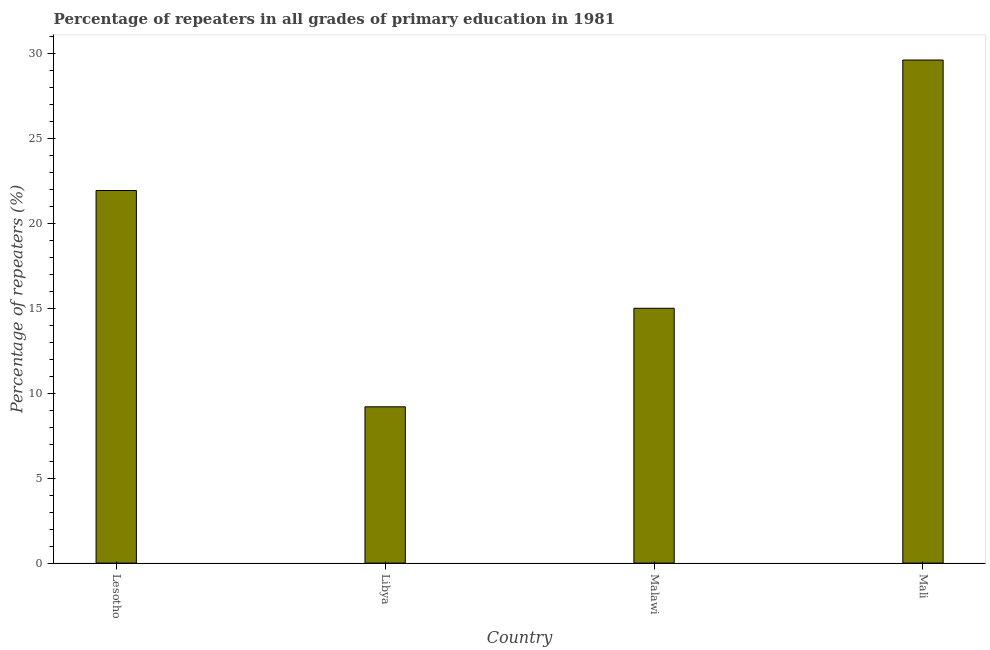Does the graph contain any zero values?
Make the answer very short. No. What is the title of the graph?
Offer a very short reply. Percentage of repeaters in all grades of primary education in 1981. What is the label or title of the X-axis?
Your response must be concise. Country. What is the label or title of the Y-axis?
Your response must be concise. Percentage of repeaters (%). What is the percentage of repeaters in primary education in Mali?
Provide a short and direct response. 29.59. Across all countries, what is the maximum percentage of repeaters in primary education?
Your answer should be very brief. 29.59. Across all countries, what is the minimum percentage of repeaters in primary education?
Give a very brief answer. 9.19. In which country was the percentage of repeaters in primary education maximum?
Your answer should be compact. Mali. In which country was the percentage of repeaters in primary education minimum?
Offer a very short reply. Libya. What is the sum of the percentage of repeaters in primary education?
Ensure brevity in your answer.  75.68. What is the difference between the percentage of repeaters in primary education in Lesotho and Malawi?
Offer a terse response. 6.93. What is the average percentage of repeaters in primary education per country?
Offer a terse response. 18.92. What is the median percentage of repeaters in primary education?
Provide a short and direct response. 18.45. In how many countries, is the percentage of repeaters in primary education greater than 30 %?
Give a very brief answer. 0. What is the ratio of the percentage of repeaters in primary education in Lesotho to that in Malawi?
Offer a terse response. 1.46. What is the difference between the highest and the second highest percentage of repeaters in primary education?
Your answer should be compact. 7.67. What is the difference between the highest and the lowest percentage of repeaters in primary education?
Your answer should be compact. 20.4. In how many countries, is the percentage of repeaters in primary education greater than the average percentage of repeaters in primary education taken over all countries?
Provide a short and direct response. 2. Are all the bars in the graph horizontal?
Make the answer very short. No. How many countries are there in the graph?
Give a very brief answer. 4. What is the Percentage of repeaters (%) in Lesotho?
Offer a terse response. 21.92. What is the Percentage of repeaters (%) in Libya?
Give a very brief answer. 9.19. What is the Percentage of repeaters (%) of Malawi?
Your response must be concise. 14.99. What is the Percentage of repeaters (%) of Mali?
Ensure brevity in your answer.  29.59. What is the difference between the Percentage of repeaters (%) in Lesotho and Libya?
Offer a terse response. 12.72. What is the difference between the Percentage of repeaters (%) in Lesotho and Malawi?
Provide a succinct answer. 6.93. What is the difference between the Percentage of repeaters (%) in Lesotho and Mali?
Your answer should be compact. -7.67. What is the difference between the Percentage of repeaters (%) in Libya and Malawi?
Keep it short and to the point. -5.8. What is the difference between the Percentage of repeaters (%) in Libya and Mali?
Offer a terse response. -20.4. What is the difference between the Percentage of repeaters (%) in Malawi and Mali?
Offer a very short reply. -14.6. What is the ratio of the Percentage of repeaters (%) in Lesotho to that in Libya?
Offer a terse response. 2.38. What is the ratio of the Percentage of repeaters (%) in Lesotho to that in Malawi?
Your answer should be compact. 1.46. What is the ratio of the Percentage of repeaters (%) in Lesotho to that in Mali?
Your response must be concise. 0.74. What is the ratio of the Percentage of repeaters (%) in Libya to that in Malawi?
Your answer should be compact. 0.61. What is the ratio of the Percentage of repeaters (%) in Libya to that in Mali?
Provide a succinct answer. 0.31. What is the ratio of the Percentage of repeaters (%) in Malawi to that in Mali?
Provide a short and direct response. 0.51. 